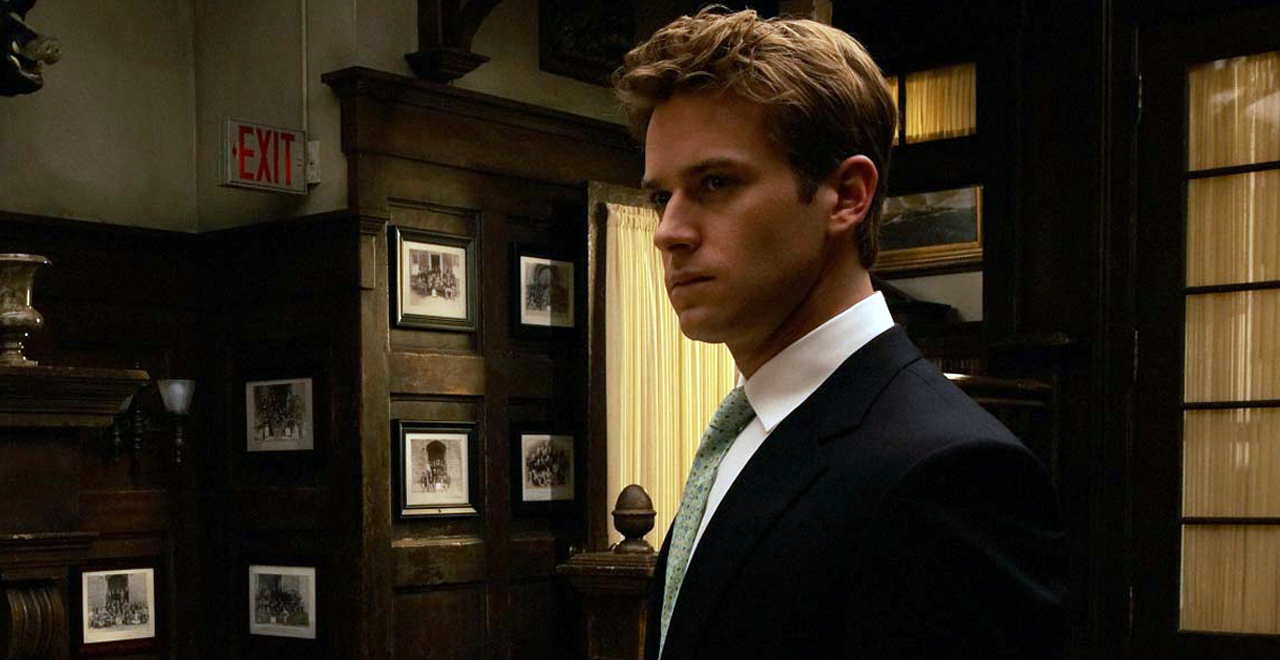Explain the visual content of the image in great detail. This image captures a young man in a refined, serious setting that suggests a moment of contemplation or tension. He is dressed sharply in a dark suit, complemented by a green vest and tie, standing with a slight turn towards something or someone out of frame. His expression is one of focused thought, adding to the gravity of the scene. The room is richly adorned with dark wood paneling and bookshelves laden with books and framed photographs, exuding an atmosphere of tradition and intellect. Notably, there's an exit sign above a door in the background, which might symbolize a narrative escape or transition, adding a layer of meaning to the scene. 